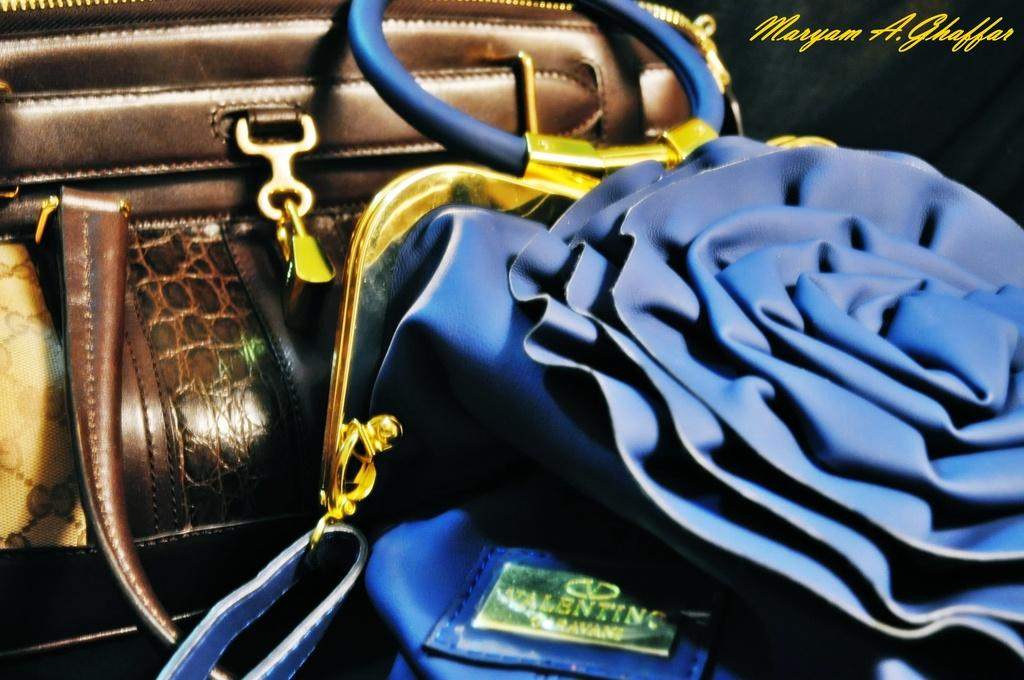What type of accessory is featured in the image? There are handbags in the image. Can you describe any additional details about the image? There is text or writing in the top right corner of the image. What type of ship can be seen sailing in the image? There is no ship present in the image; it only features handbags and text or writing. Can you tell me how many needles are used to create the handbags in the image? There is no information about the construction of the handbags or the use of needles in the image. 